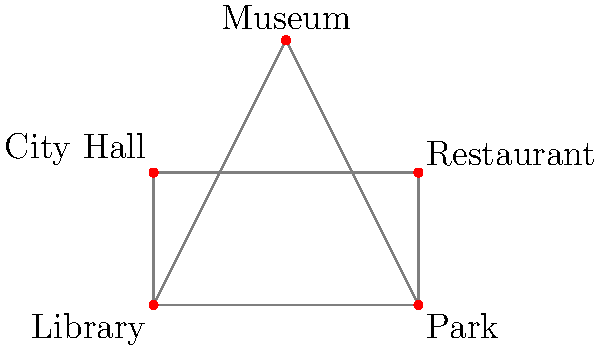Based on the simple town map of Lovington's main attractions, which location forms a central point connecting to all other locations? To determine the central location connecting to all others, let's analyze the map step-by-step:

1. Identify all locations on the map:
   - Library (bottom left)
   - Park (bottom right)
   - Museum (top center)
   - City Hall (middle left)
   - Restaurant (middle right)

2. Examine the connections:
   - The Library connects to the Park, Museum, and City Hall.
   - The Park connects to the Library, Museum, and Restaurant.
   - The Museum connects to the Library, Park, and City Hall.
   - The City Hall connects to the Library and Museum.
   - The Restaurant connects to the Park.

3. Count the connections for each location:
   - Library: 3 connections
   - Park: 3 connections
   - Museum: 3 connections
   - City Hall: 2 connections
   - Restaurant: 1 connection

4. Identify the location with the most connections:
   The Library, Park, and Museum all have 3 connections each.

5. Determine the central point:
   Among these three, the Museum is positioned at the top center of the map, forming a central point that connects to all other locations either directly or indirectly.

Therefore, the Museum forms the central point connecting to all other locations in Lovington's main attractions map.
Answer: Museum 